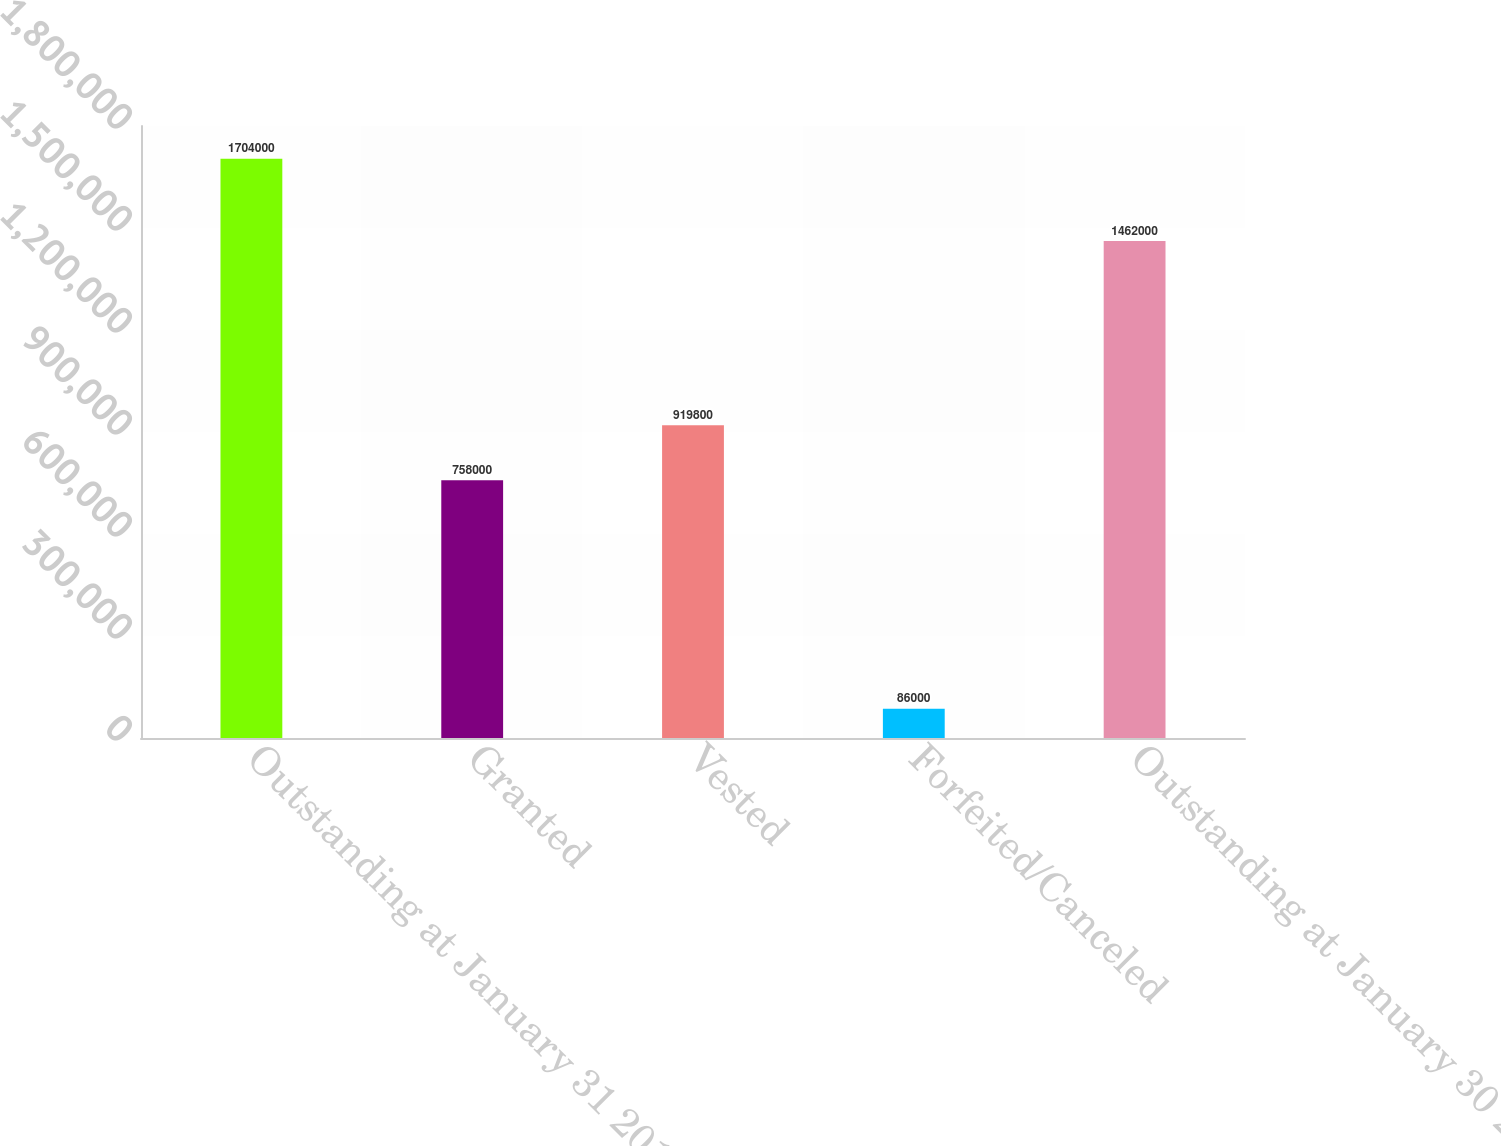Convert chart to OTSL. <chart><loc_0><loc_0><loc_500><loc_500><bar_chart><fcel>Outstanding at January 31 2015<fcel>Granted<fcel>Vested<fcel>Forfeited/Canceled<fcel>Outstanding at January 30 2016<nl><fcel>1.704e+06<fcel>758000<fcel>919800<fcel>86000<fcel>1.462e+06<nl></chart> 